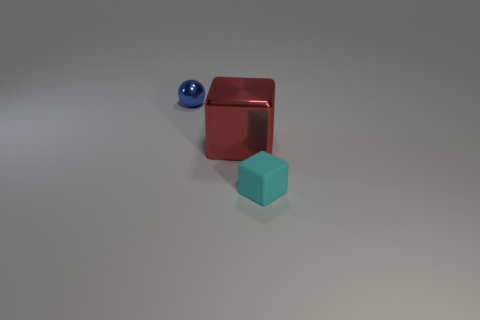Add 3 green metallic balls. How many objects exist? 6 Subtract all cyan blocks. How many blocks are left? 1 Subtract 0 brown cylinders. How many objects are left? 3 Subtract all cubes. How many objects are left? 1 Subtract 1 spheres. How many spheres are left? 0 Subtract all brown blocks. Subtract all blue cylinders. How many blocks are left? 2 Subtract all big purple rubber cylinders. Subtract all shiny objects. How many objects are left? 1 Add 2 tiny cyan matte things. How many tiny cyan matte things are left? 3 Add 1 small cyan rubber objects. How many small cyan rubber objects exist? 2 